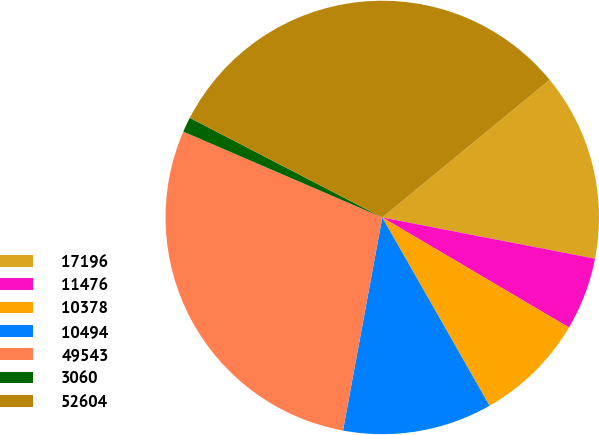Convert chart. <chart><loc_0><loc_0><loc_500><loc_500><pie_chart><fcel>17196<fcel>11476<fcel>10378<fcel>10494<fcel>49543<fcel>3060<fcel>52604<nl><fcel>14.0%<fcel>5.43%<fcel>8.28%<fcel>11.14%<fcel>28.58%<fcel>1.12%<fcel>31.44%<nl></chart> 